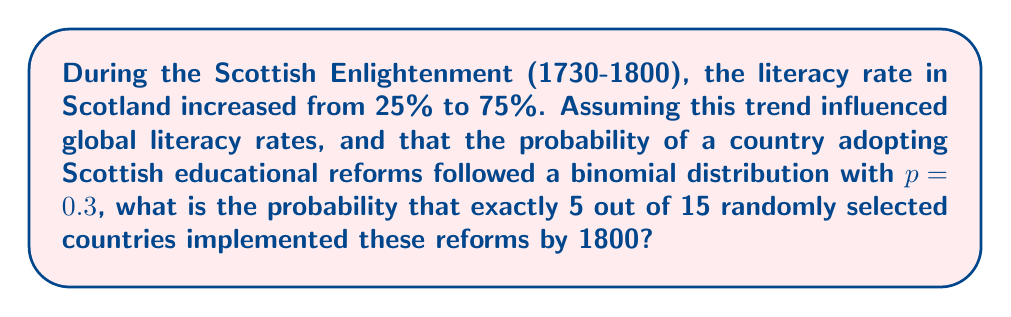Could you help me with this problem? To solve this problem, we need to use the binomial probability formula:

$$P(X=k) = \binom{n}{k} p^k (1-p)^{n-k}$$

Where:
- $n$ is the number of trials (countries in this case)
- $k$ is the number of successes (countries that implemented reforms)
- $p$ is the probability of success on each trial

Given:
- $n = 15$ (randomly selected countries)
- $k = 5$ (exactly 5 countries implementing reforms)
- $p = 0.3$ (probability of a country adopting reforms)

Step 1: Calculate the binomial coefficient $\binom{15}{5}$
$$\binom{15}{5} = \frac{15!}{5!(15-5)!} = \frac{15!}{5!10!} = 3003$$

Step 2: Calculate $p^k$
$$0.3^5 = 0.00243$$

Step 3: Calculate $(1-p)^{n-k}$
$$(1-0.3)^{15-5} = 0.7^{10} = 0.0282475249$$

Step 4: Multiply all components
$$P(X=5) = 3003 \times 0.00243 \times 0.0282475249 = 0.2061$$

Therefore, the probability of exactly 5 out of 15 randomly selected countries implementing Scottish educational reforms by 1800 is approximately 0.2061 or 20.61%.
Answer: 0.2061 